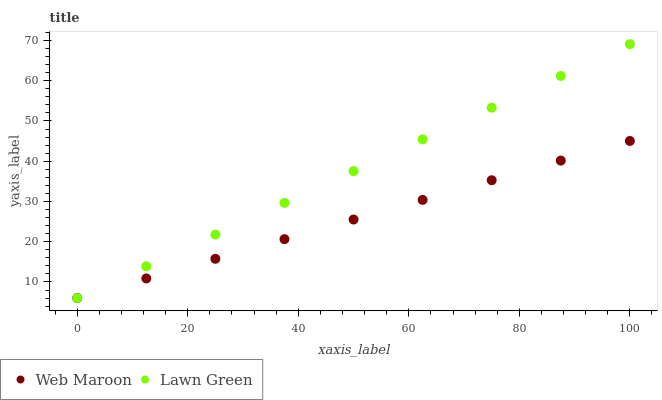Does Web Maroon have the minimum area under the curve?
Answer yes or no. Yes. Does Lawn Green have the maximum area under the curve?
Answer yes or no. Yes. Does Web Maroon have the maximum area under the curve?
Answer yes or no. No. Is Web Maroon the smoothest?
Answer yes or no. Yes. Is Lawn Green the roughest?
Answer yes or no. Yes. Is Web Maroon the roughest?
Answer yes or no. No. Does Lawn Green have the lowest value?
Answer yes or no. Yes. Does Lawn Green have the highest value?
Answer yes or no. Yes. Does Web Maroon have the highest value?
Answer yes or no. No. Does Lawn Green intersect Web Maroon?
Answer yes or no. Yes. Is Lawn Green less than Web Maroon?
Answer yes or no. No. Is Lawn Green greater than Web Maroon?
Answer yes or no. No. 